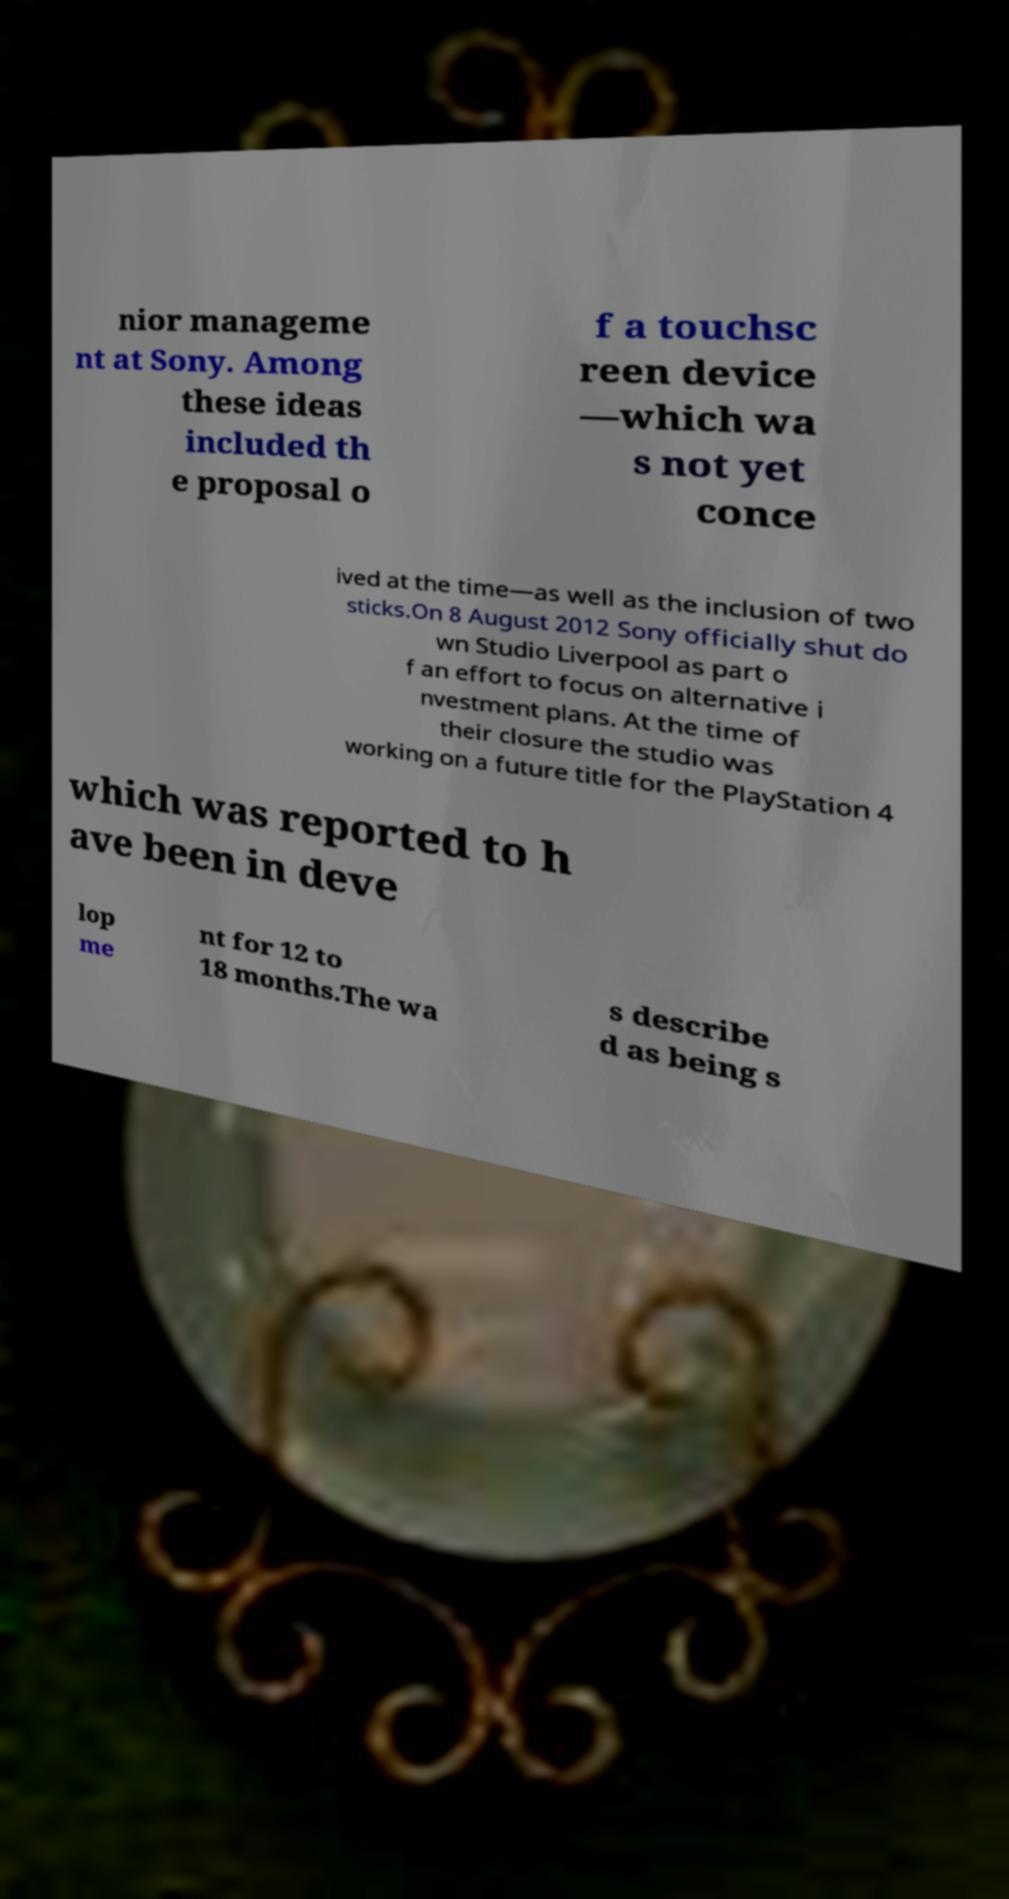I need the written content from this picture converted into text. Can you do that? nior manageme nt at Sony. Among these ideas included th e proposal o f a touchsc reen device —which wa s not yet conce ived at the time—as well as the inclusion of two sticks.On 8 August 2012 Sony officially shut do wn Studio Liverpool as part o f an effort to focus on alternative i nvestment plans. At the time of their closure the studio was working on a future title for the PlayStation 4 which was reported to h ave been in deve lop me nt for 12 to 18 months.The wa s describe d as being s 